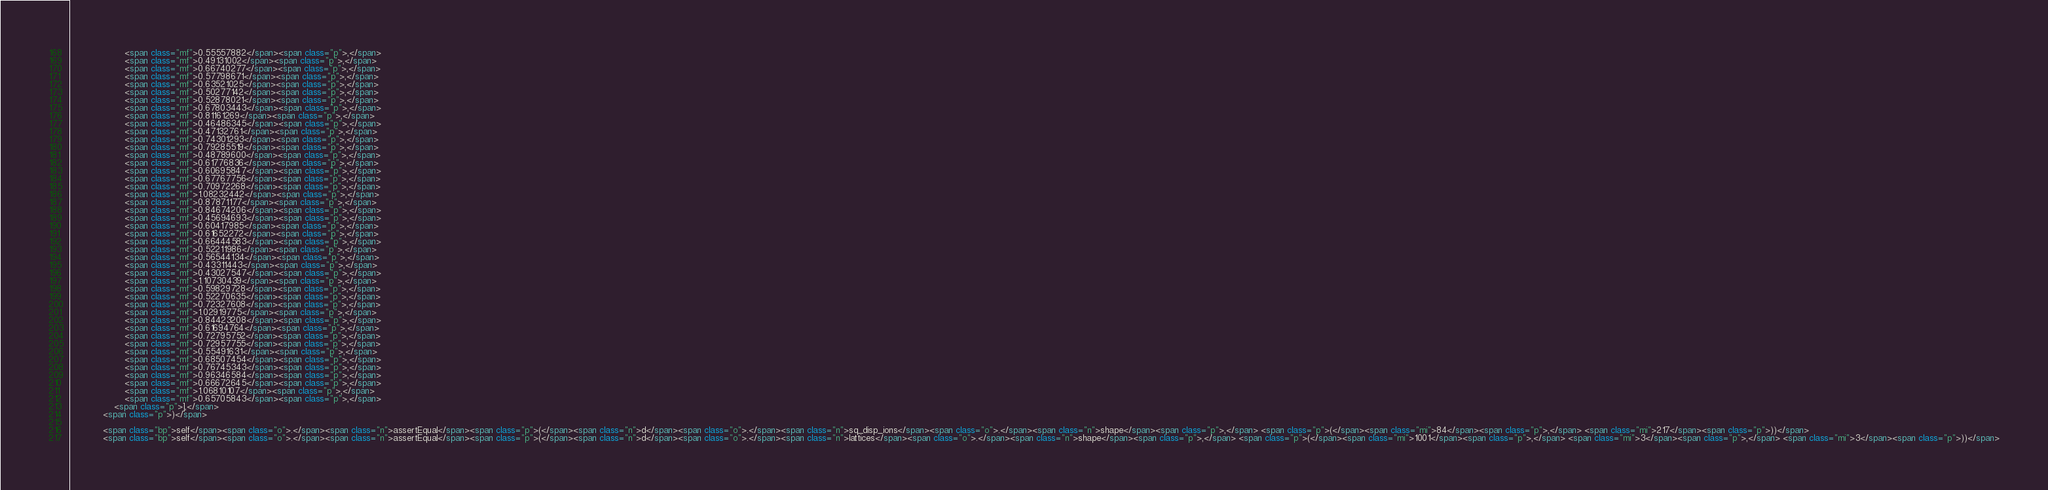Convert code to text. <code><loc_0><loc_0><loc_500><loc_500><_HTML_>                    <span class="mf">0.55557882</span><span class="p">,</span>
                    <span class="mf">0.49131002</span><span class="p">,</span>
                    <span class="mf">0.66740277</span><span class="p">,</span>
                    <span class="mf">0.57798671</span><span class="p">,</span>
                    <span class="mf">0.63521025</span><span class="p">,</span>
                    <span class="mf">0.50277142</span><span class="p">,</span>
                    <span class="mf">0.52878021</span><span class="p">,</span>
                    <span class="mf">0.67803443</span><span class="p">,</span>
                    <span class="mf">0.81161269</span><span class="p">,</span>
                    <span class="mf">0.46486345</span><span class="p">,</span>
                    <span class="mf">0.47132761</span><span class="p">,</span>
                    <span class="mf">0.74301293</span><span class="p">,</span>
                    <span class="mf">0.79285519</span><span class="p">,</span>
                    <span class="mf">0.48789600</span><span class="p">,</span>
                    <span class="mf">0.61776836</span><span class="p">,</span>
                    <span class="mf">0.60695847</span><span class="p">,</span>
                    <span class="mf">0.67767756</span><span class="p">,</span>
                    <span class="mf">0.70972268</span><span class="p">,</span>
                    <span class="mf">1.08232442</span><span class="p">,</span>
                    <span class="mf">0.87871177</span><span class="p">,</span>
                    <span class="mf">0.84674206</span><span class="p">,</span>
                    <span class="mf">0.45694693</span><span class="p">,</span>
                    <span class="mf">0.60417985</span><span class="p">,</span>
                    <span class="mf">0.61652272</span><span class="p">,</span>
                    <span class="mf">0.66444583</span><span class="p">,</span>
                    <span class="mf">0.52211986</span><span class="p">,</span>
                    <span class="mf">0.56544134</span><span class="p">,</span>
                    <span class="mf">0.43311443</span><span class="p">,</span>
                    <span class="mf">0.43027547</span><span class="p">,</span>
                    <span class="mf">1.10730439</span><span class="p">,</span>
                    <span class="mf">0.59829728</span><span class="p">,</span>
                    <span class="mf">0.52270635</span><span class="p">,</span>
                    <span class="mf">0.72327608</span><span class="p">,</span>
                    <span class="mf">1.02919775</span><span class="p">,</span>
                    <span class="mf">0.84423208</span><span class="p">,</span>
                    <span class="mf">0.61694764</span><span class="p">,</span>
                    <span class="mf">0.72795752</span><span class="p">,</span>
                    <span class="mf">0.72957755</span><span class="p">,</span>
                    <span class="mf">0.55491631</span><span class="p">,</span>
                    <span class="mf">0.68507454</span><span class="p">,</span>
                    <span class="mf">0.76745343</span><span class="p">,</span>
                    <span class="mf">0.96346584</span><span class="p">,</span>
                    <span class="mf">0.66672645</span><span class="p">,</span>
                    <span class="mf">1.06810107</span><span class="p">,</span>
                    <span class="mf">0.65705843</span><span class="p">,</span>
                <span class="p">],</span>
            <span class="p">)</span>

            <span class="bp">self</span><span class="o">.</span><span class="n">assertEqual</span><span class="p">(</span><span class="n">d</span><span class="o">.</span><span class="n">sq_disp_ions</span><span class="o">.</span><span class="n">shape</span><span class="p">,</span> <span class="p">(</span><span class="mi">84</span><span class="p">,</span> <span class="mi">217</span><span class="p">))</span>
            <span class="bp">self</span><span class="o">.</span><span class="n">assertEqual</span><span class="p">(</span><span class="n">d</span><span class="o">.</span><span class="n">lattices</span><span class="o">.</span><span class="n">shape</span><span class="p">,</span> <span class="p">(</span><span class="mi">1001</span><span class="p">,</span> <span class="mi">3</span><span class="p">,</span> <span class="mi">3</span><span class="p">))</span></code> 